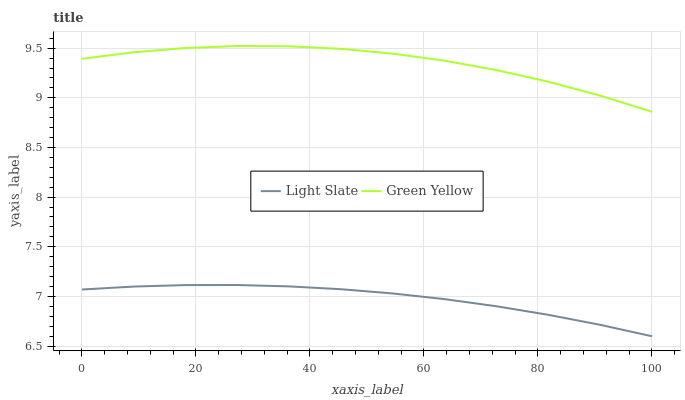Does Light Slate have the minimum area under the curve?
Answer yes or no. Yes. Does Green Yellow have the maximum area under the curve?
Answer yes or no. Yes. Does Green Yellow have the minimum area under the curve?
Answer yes or no. No. Is Light Slate the smoothest?
Answer yes or no. Yes. Is Green Yellow the roughest?
Answer yes or no. Yes. Is Green Yellow the smoothest?
Answer yes or no. No. Does Green Yellow have the lowest value?
Answer yes or no. No. Does Green Yellow have the highest value?
Answer yes or no. Yes. Is Light Slate less than Green Yellow?
Answer yes or no. Yes. Is Green Yellow greater than Light Slate?
Answer yes or no. Yes. Does Light Slate intersect Green Yellow?
Answer yes or no. No. 